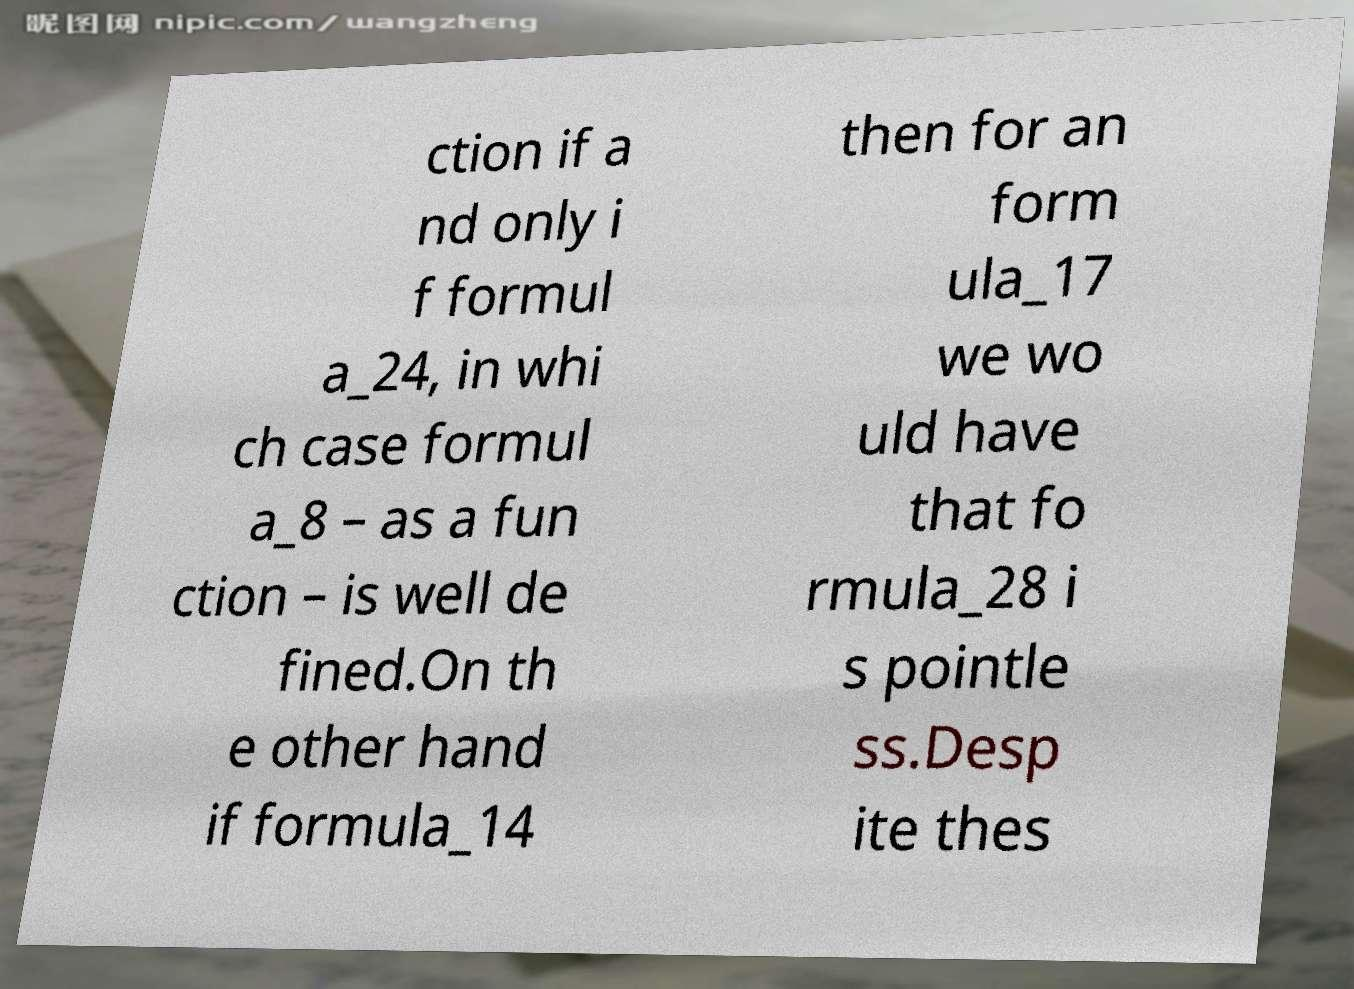Can you accurately transcribe the text from the provided image for me? ction if a nd only i f formul a_24, in whi ch case formul a_8 – as a fun ction – is well de fined.On th e other hand if formula_14 then for an form ula_17 we wo uld have that fo rmula_28 i s pointle ss.Desp ite thes 